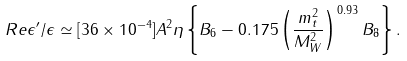Convert formula to latex. <formula><loc_0><loc_0><loc_500><loc_500>R e \epsilon ^ { \prime } / \epsilon \simeq [ 3 6 \times 1 0 ^ { - 4 } ] A ^ { 2 } \eta \left \{ B _ { 6 } - 0 . 1 7 5 \left ( \frac { m _ { t } ^ { 2 } } { M _ { W } ^ { 2 } } \right ) ^ { 0 . 9 3 } B _ { 8 } \right \} .</formula> 